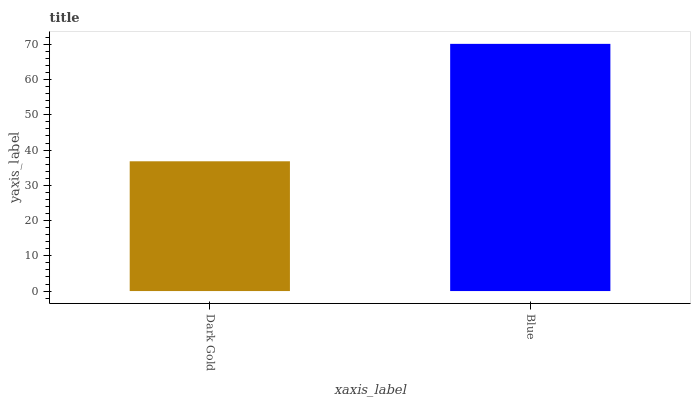Is Dark Gold the minimum?
Answer yes or no. Yes. Is Blue the maximum?
Answer yes or no. Yes. Is Blue the minimum?
Answer yes or no. No. Is Blue greater than Dark Gold?
Answer yes or no. Yes. Is Dark Gold less than Blue?
Answer yes or no. Yes. Is Dark Gold greater than Blue?
Answer yes or no. No. Is Blue less than Dark Gold?
Answer yes or no. No. Is Blue the high median?
Answer yes or no. Yes. Is Dark Gold the low median?
Answer yes or no. Yes. Is Dark Gold the high median?
Answer yes or no. No. Is Blue the low median?
Answer yes or no. No. 